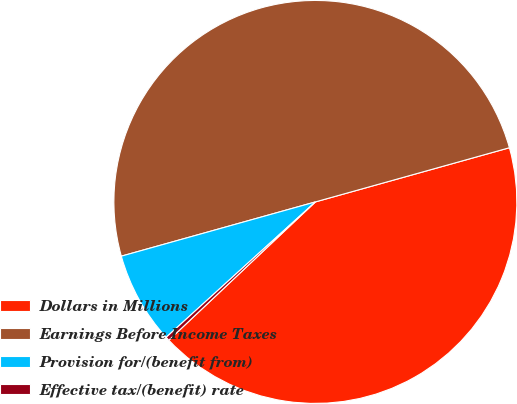Convert chart. <chart><loc_0><loc_0><loc_500><loc_500><pie_chart><fcel>Dollars in Millions<fcel>Earnings Before Income Taxes<fcel>Provision for/(benefit from)<fcel>Effective tax/(benefit) rate<nl><fcel>42.29%<fcel>50.0%<fcel>7.39%<fcel>0.31%<nl></chart> 